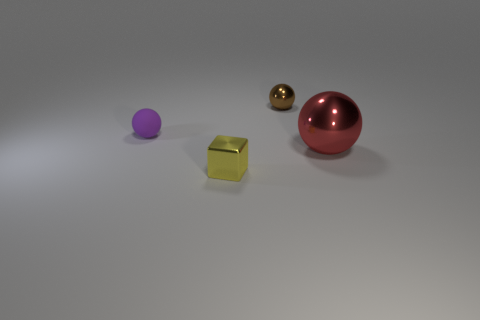What is the ball to the left of the tiny metal object that is behind the small yellow cube made of?
Offer a terse response. Rubber. There is a tiny matte thing; are there any objects behind it?
Keep it short and to the point. Yes. There is a metal cube; is it the same size as the shiny ball that is behind the purple matte ball?
Provide a succinct answer. Yes. There is a brown metal object that is the same shape as the tiny purple rubber object; what size is it?
Provide a succinct answer. Small. Is there anything else that is the same material as the tiny purple thing?
Give a very brief answer. No. There is a metal ball to the left of the red thing; is its size the same as the object to the right of the brown shiny ball?
Your answer should be compact. No. How many small things are either yellow rubber cubes or purple spheres?
Make the answer very short. 1. What number of objects are in front of the red shiny sphere and left of the metal block?
Keep it short and to the point. 0. Is the material of the tiny yellow object the same as the tiny ball that is in front of the brown object?
Ensure brevity in your answer.  No. What number of brown objects are spheres or metallic balls?
Give a very brief answer. 1. 